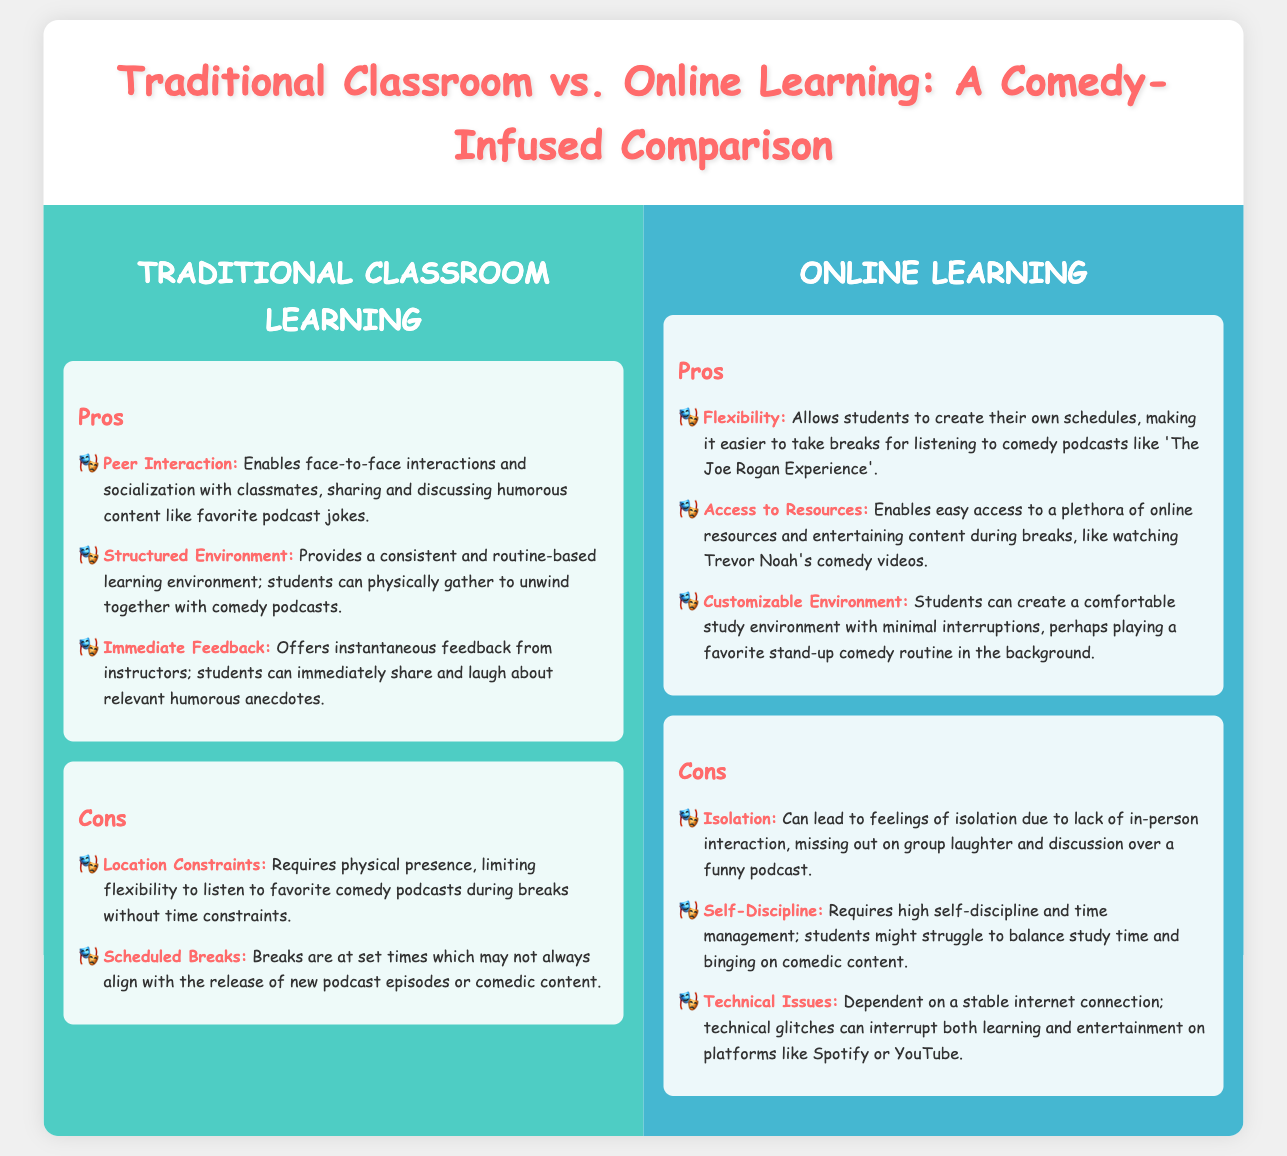What are the pros of Traditional Classroom Learning? The pros listed in the document highlight peer interaction, structured environment, and immediate feedback.
Answer: Peer Interaction, Structured Environment, Immediate Feedback What is one con of Online Learning? The document mentions isolation, self-discipline, and technical issues as cons of Online Learning.
Answer: Isolation How does Traditional Classroom Learning enable socialization? The pros section states that it allows face-to-face interactions with classmates for sharing humorous content.
Answer: Face-to-face interactions What is a major advantage of Online Learning regarding scheduling? The pros of Online Learning emphasize flexibility in creating personal schedules.
Answer: Flexibility Which comedian's podcast is mentioned as an example of content students might listen to during breaks? The document references 'The Joe Rogan Experience' as a comedy podcast students might enjoy.
Answer: The Joe Rogan Experience How does the structured environment of Traditional Classroom Learning benefit students? It provides a consistent routine that allows students to unwind together with comedy content.
Answer: Consistent routine What is a challenge related to self-discipline in Online Learning? The document indicates that managing study time versus comedic content can be a struggle for students.
Answer: Balancing study time and comedic content What type of environment can students create in Online Learning? The pros section mentions that students can create a comfortable study environment with minimal interruptions.
Answer: Comfortable study environment 